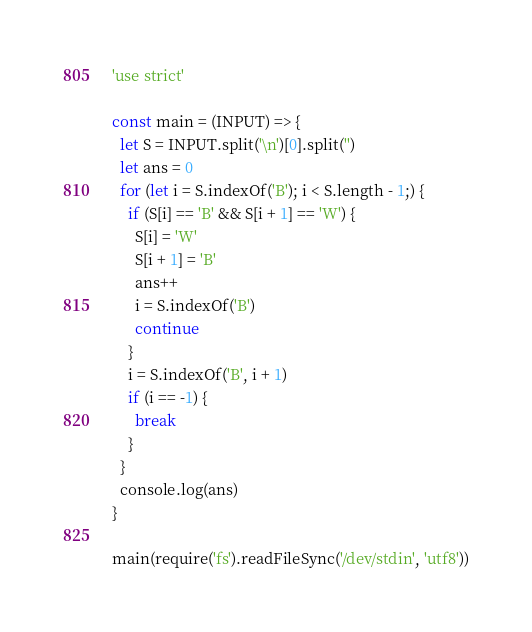Convert code to text. <code><loc_0><loc_0><loc_500><loc_500><_JavaScript_>'use strict'

const main = (INPUT) => {
  let S = INPUT.split('\n')[0].split('')
  let ans = 0
  for (let i = S.indexOf('B'); i < S.length - 1;) {
    if (S[i] == 'B' && S[i + 1] == 'W') {
      S[i] = 'W'
      S[i + 1] = 'B'
      ans++
      i = S.indexOf('B')
      continue
    }
    i = S.indexOf('B', i + 1)
    if (i == -1) {
      break
    }
  }
  console.log(ans)
}

main(require('fs').readFileSync('/dev/stdin', 'utf8'))
</code> 